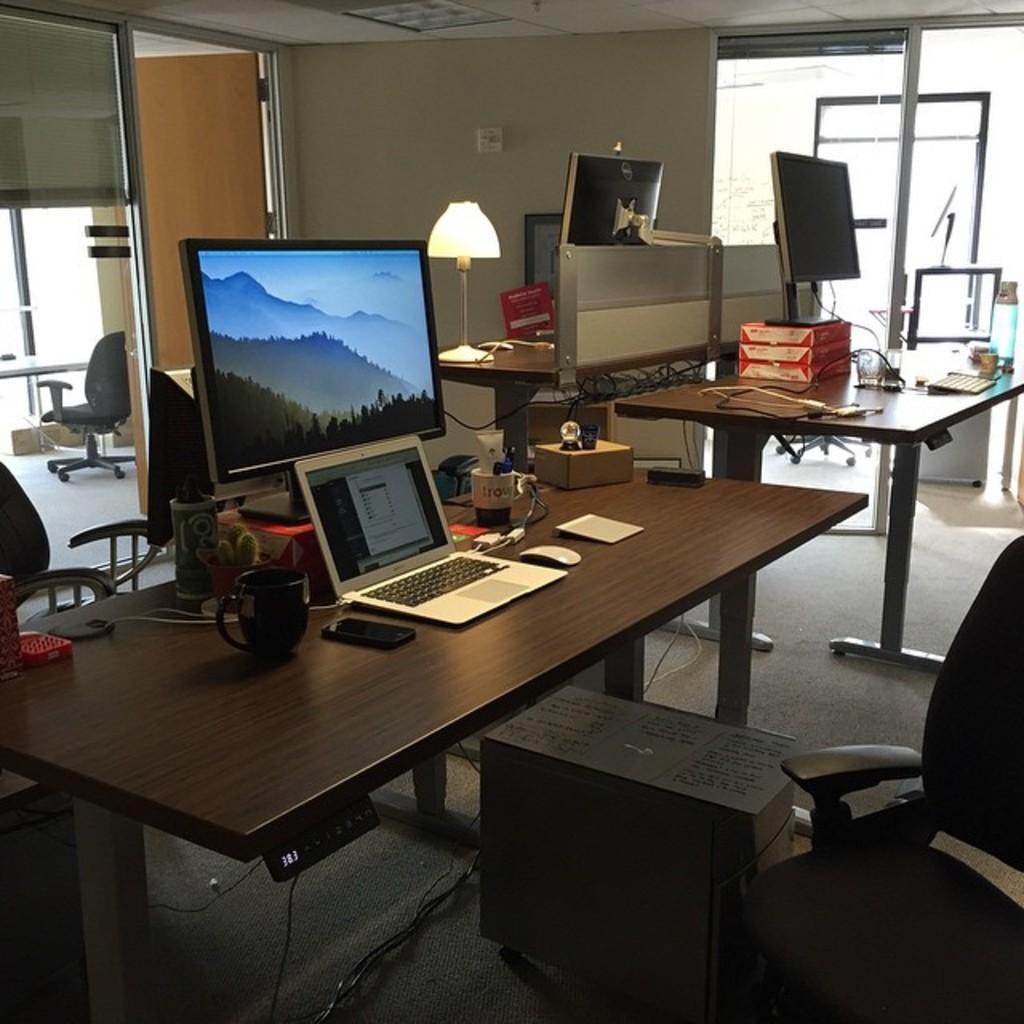Can you describe this image briefly? In this picture we can see a table. On the table there is a monitor, laptop, cup, and a box. These are the chairs and this is floor. On the background there is a wall and this is lamp. 